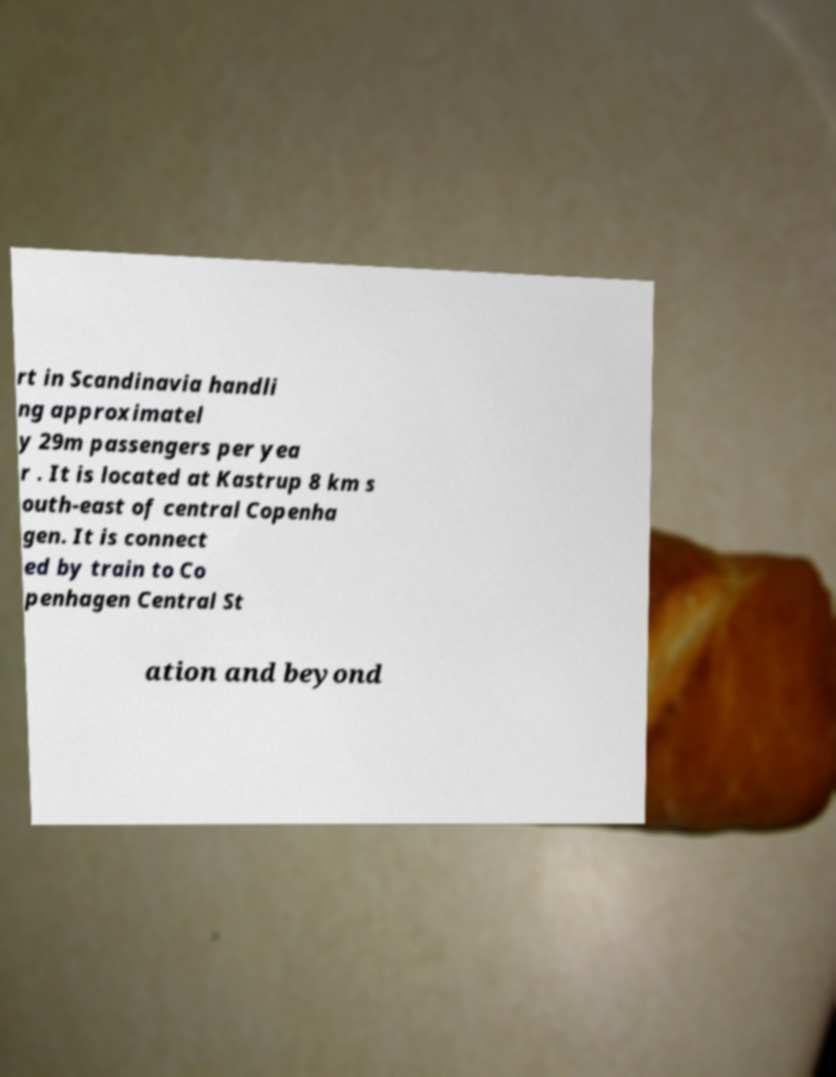I need the written content from this picture converted into text. Can you do that? rt in Scandinavia handli ng approximatel y 29m passengers per yea r . It is located at Kastrup 8 km s outh-east of central Copenha gen. It is connect ed by train to Co penhagen Central St ation and beyond 